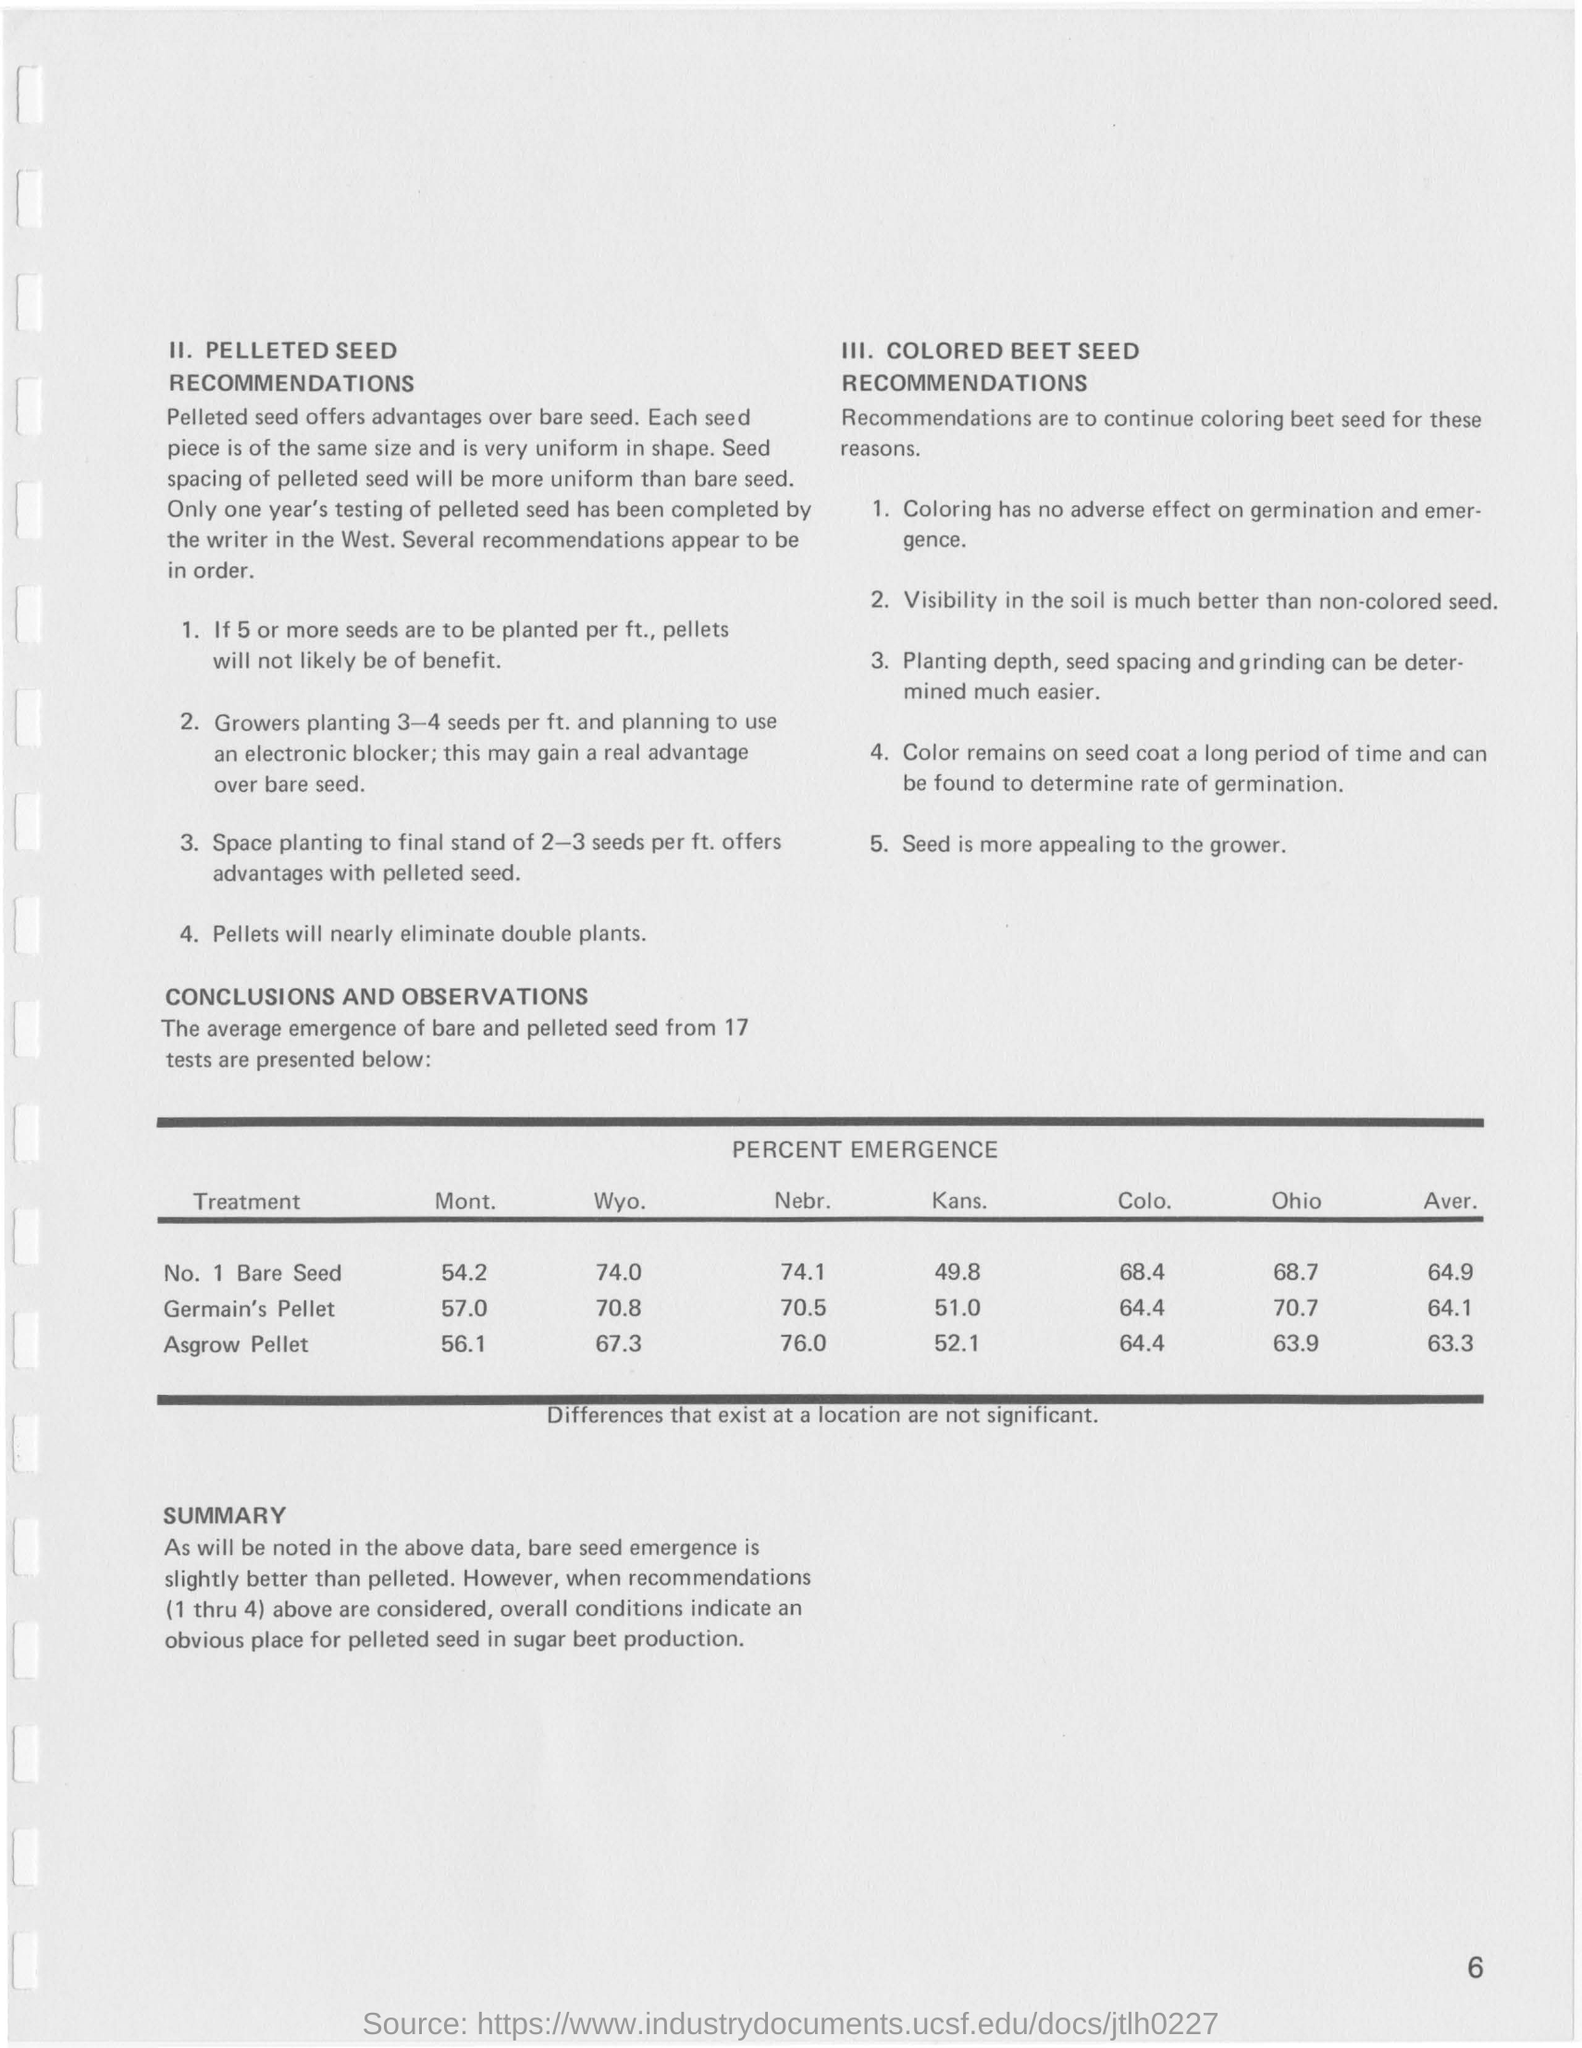What is the Percent emergence of No. 1 Bare Seed in Mont. ?
Make the answer very short. 54.2. What is the average percent emergence of Germain's Pellet seeds?
Ensure brevity in your answer.  64.1. What is the percent emergence of Asgrow pellet seeds in Ohio?
Your answer should be compact. 63.9. What is the average percent emergence of Asgrow Pellet seeds?
Ensure brevity in your answer.  63.3. 